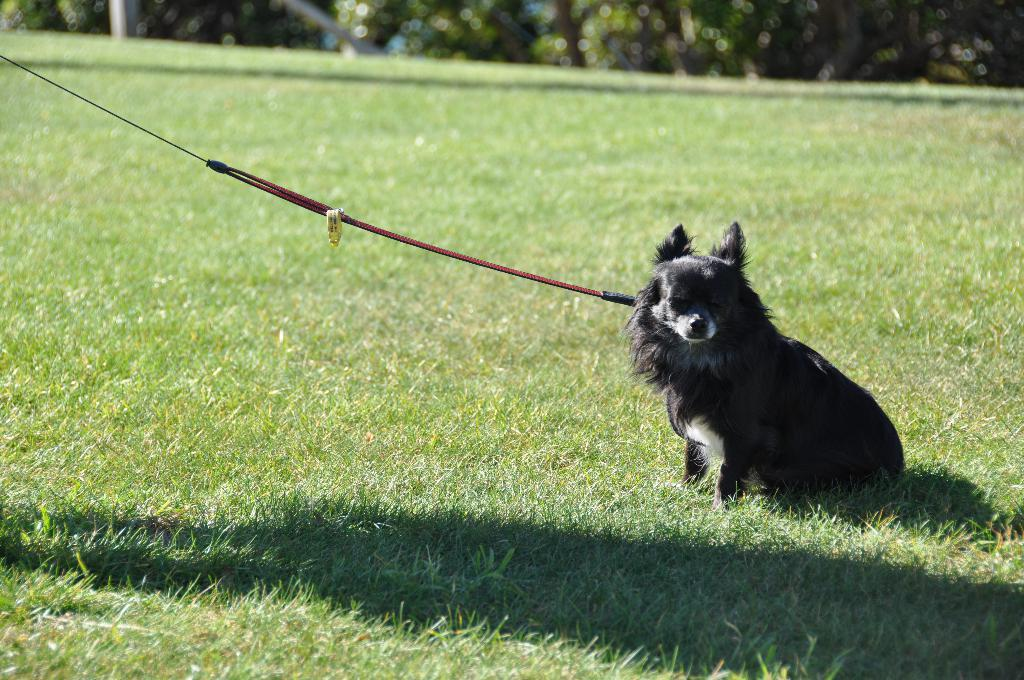What animal is present in the image? There is a dog in the image. Where is the dog located? The dog is on the ground. How is the dog restrained in the image? The dog is tied with a rope. What can be seen in the background of the image? There are trees in the background of the image. What sense is the dog using to interact with the seat in the image? There is no seat present in the image, so the dog cannot be interacting with a seat. 